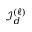Convert formula to latex. <formula><loc_0><loc_0><loc_500><loc_500>{ \mathcal { I } } _ { d } ^ { ( \ell ) }</formula> 